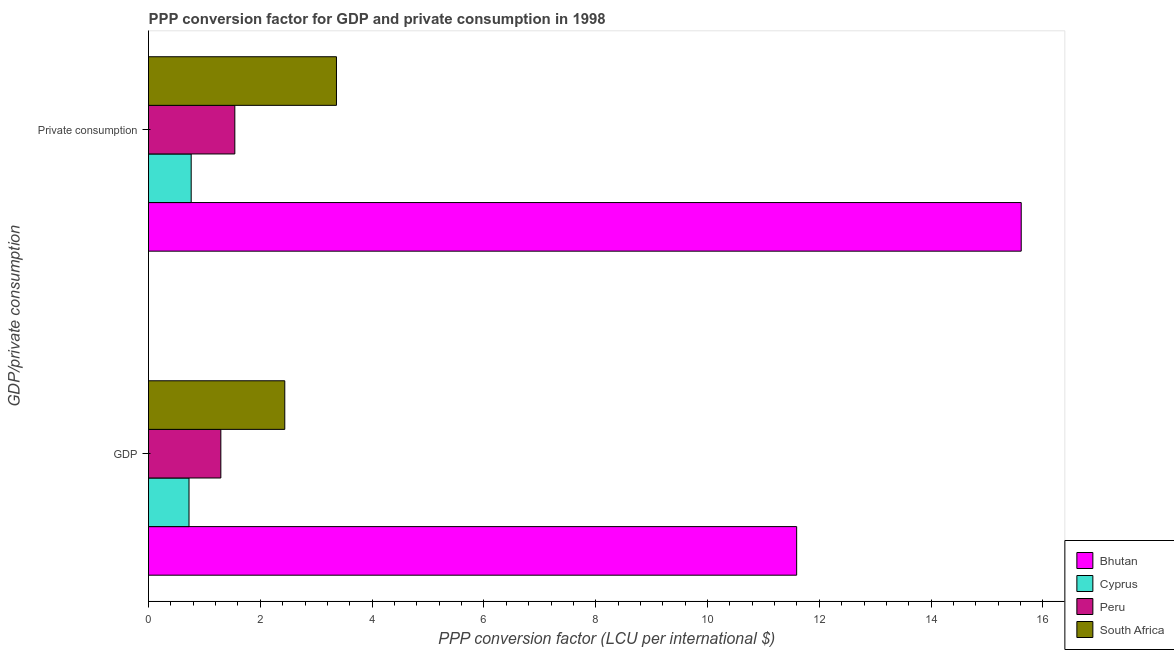How many different coloured bars are there?
Provide a succinct answer. 4. Are the number of bars per tick equal to the number of legend labels?
Your answer should be compact. Yes. What is the label of the 1st group of bars from the top?
Your response must be concise.  Private consumption. What is the ppp conversion factor for private consumption in Cyprus?
Provide a succinct answer. 0.76. Across all countries, what is the maximum ppp conversion factor for gdp?
Give a very brief answer. 11.59. Across all countries, what is the minimum ppp conversion factor for private consumption?
Ensure brevity in your answer.  0.76. In which country was the ppp conversion factor for private consumption maximum?
Provide a short and direct response. Bhutan. In which country was the ppp conversion factor for gdp minimum?
Provide a succinct answer. Cyprus. What is the total ppp conversion factor for private consumption in the graph?
Provide a short and direct response. 21.28. What is the difference between the ppp conversion factor for private consumption in South Africa and that in Bhutan?
Give a very brief answer. -12.25. What is the difference between the ppp conversion factor for private consumption in South Africa and the ppp conversion factor for gdp in Cyprus?
Your response must be concise. 2.64. What is the average ppp conversion factor for gdp per country?
Provide a short and direct response. 4.01. What is the difference between the ppp conversion factor for gdp and ppp conversion factor for private consumption in Peru?
Keep it short and to the point. -0.25. What is the ratio of the ppp conversion factor for gdp in South Africa to that in Cyprus?
Your response must be concise. 3.37. What does the 4th bar from the top in GDP represents?
Provide a succinct answer. Bhutan. What does the 2nd bar from the bottom in GDP represents?
Keep it short and to the point. Cyprus. Are all the bars in the graph horizontal?
Offer a very short reply. Yes. Does the graph contain any zero values?
Ensure brevity in your answer.  No. Does the graph contain grids?
Offer a terse response. No. Where does the legend appear in the graph?
Your answer should be very brief. Bottom right. What is the title of the graph?
Ensure brevity in your answer.  PPP conversion factor for GDP and private consumption in 1998. What is the label or title of the X-axis?
Ensure brevity in your answer.  PPP conversion factor (LCU per international $). What is the label or title of the Y-axis?
Ensure brevity in your answer.  GDP/private consumption. What is the PPP conversion factor (LCU per international $) in Bhutan in GDP?
Keep it short and to the point. 11.59. What is the PPP conversion factor (LCU per international $) in Cyprus in GDP?
Keep it short and to the point. 0.72. What is the PPP conversion factor (LCU per international $) of Peru in GDP?
Provide a succinct answer. 1.29. What is the PPP conversion factor (LCU per international $) of South Africa in GDP?
Provide a succinct answer. 2.44. What is the PPP conversion factor (LCU per international $) of Bhutan in  Private consumption?
Your answer should be compact. 15.61. What is the PPP conversion factor (LCU per international $) in Cyprus in  Private consumption?
Offer a terse response. 0.76. What is the PPP conversion factor (LCU per international $) in Peru in  Private consumption?
Provide a short and direct response. 1.54. What is the PPP conversion factor (LCU per international $) of South Africa in  Private consumption?
Your response must be concise. 3.36. Across all GDP/private consumption, what is the maximum PPP conversion factor (LCU per international $) in Bhutan?
Give a very brief answer. 15.61. Across all GDP/private consumption, what is the maximum PPP conversion factor (LCU per international $) in Cyprus?
Your answer should be very brief. 0.76. Across all GDP/private consumption, what is the maximum PPP conversion factor (LCU per international $) in Peru?
Ensure brevity in your answer.  1.54. Across all GDP/private consumption, what is the maximum PPP conversion factor (LCU per international $) in South Africa?
Make the answer very short. 3.36. Across all GDP/private consumption, what is the minimum PPP conversion factor (LCU per international $) in Bhutan?
Provide a succinct answer. 11.59. Across all GDP/private consumption, what is the minimum PPP conversion factor (LCU per international $) of Cyprus?
Make the answer very short. 0.72. Across all GDP/private consumption, what is the minimum PPP conversion factor (LCU per international $) of Peru?
Your answer should be compact. 1.29. Across all GDP/private consumption, what is the minimum PPP conversion factor (LCU per international $) in South Africa?
Ensure brevity in your answer.  2.44. What is the total PPP conversion factor (LCU per international $) of Bhutan in the graph?
Offer a terse response. 27.21. What is the total PPP conversion factor (LCU per international $) in Cyprus in the graph?
Your answer should be very brief. 1.49. What is the total PPP conversion factor (LCU per international $) in Peru in the graph?
Ensure brevity in your answer.  2.84. What is the total PPP conversion factor (LCU per international $) of South Africa in the graph?
Ensure brevity in your answer.  5.8. What is the difference between the PPP conversion factor (LCU per international $) in Bhutan in GDP and that in  Private consumption?
Your answer should be very brief. -4.02. What is the difference between the PPP conversion factor (LCU per international $) in Cyprus in GDP and that in  Private consumption?
Keep it short and to the point. -0.04. What is the difference between the PPP conversion factor (LCU per international $) in Peru in GDP and that in  Private consumption?
Provide a short and direct response. -0.25. What is the difference between the PPP conversion factor (LCU per international $) of South Africa in GDP and that in  Private consumption?
Make the answer very short. -0.92. What is the difference between the PPP conversion factor (LCU per international $) in Bhutan in GDP and the PPP conversion factor (LCU per international $) in Cyprus in  Private consumption?
Offer a terse response. 10.83. What is the difference between the PPP conversion factor (LCU per international $) of Bhutan in GDP and the PPP conversion factor (LCU per international $) of Peru in  Private consumption?
Give a very brief answer. 10.05. What is the difference between the PPP conversion factor (LCU per international $) of Bhutan in GDP and the PPP conversion factor (LCU per international $) of South Africa in  Private consumption?
Provide a short and direct response. 8.23. What is the difference between the PPP conversion factor (LCU per international $) in Cyprus in GDP and the PPP conversion factor (LCU per international $) in Peru in  Private consumption?
Offer a very short reply. -0.82. What is the difference between the PPP conversion factor (LCU per international $) in Cyprus in GDP and the PPP conversion factor (LCU per international $) in South Africa in  Private consumption?
Make the answer very short. -2.64. What is the difference between the PPP conversion factor (LCU per international $) of Peru in GDP and the PPP conversion factor (LCU per international $) of South Africa in  Private consumption?
Ensure brevity in your answer.  -2.07. What is the average PPP conversion factor (LCU per international $) of Bhutan per GDP/private consumption?
Ensure brevity in your answer.  13.6. What is the average PPP conversion factor (LCU per international $) in Cyprus per GDP/private consumption?
Make the answer very short. 0.74. What is the average PPP conversion factor (LCU per international $) of Peru per GDP/private consumption?
Provide a succinct answer. 1.42. What is the average PPP conversion factor (LCU per international $) of South Africa per GDP/private consumption?
Provide a succinct answer. 2.9. What is the difference between the PPP conversion factor (LCU per international $) of Bhutan and PPP conversion factor (LCU per international $) of Cyprus in GDP?
Make the answer very short. 10.87. What is the difference between the PPP conversion factor (LCU per international $) in Bhutan and PPP conversion factor (LCU per international $) in Peru in GDP?
Offer a terse response. 10.3. What is the difference between the PPP conversion factor (LCU per international $) of Bhutan and PPP conversion factor (LCU per international $) of South Africa in GDP?
Your answer should be very brief. 9.16. What is the difference between the PPP conversion factor (LCU per international $) in Cyprus and PPP conversion factor (LCU per international $) in Peru in GDP?
Ensure brevity in your answer.  -0.57. What is the difference between the PPP conversion factor (LCU per international $) of Cyprus and PPP conversion factor (LCU per international $) of South Africa in GDP?
Provide a succinct answer. -1.71. What is the difference between the PPP conversion factor (LCU per international $) of Peru and PPP conversion factor (LCU per international $) of South Africa in GDP?
Your answer should be compact. -1.14. What is the difference between the PPP conversion factor (LCU per international $) in Bhutan and PPP conversion factor (LCU per international $) in Cyprus in  Private consumption?
Give a very brief answer. 14.85. What is the difference between the PPP conversion factor (LCU per international $) in Bhutan and PPP conversion factor (LCU per international $) in Peru in  Private consumption?
Your response must be concise. 14.07. What is the difference between the PPP conversion factor (LCU per international $) in Bhutan and PPP conversion factor (LCU per international $) in South Africa in  Private consumption?
Your answer should be compact. 12.25. What is the difference between the PPP conversion factor (LCU per international $) in Cyprus and PPP conversion factor (LCU per international $) in Peru in  Private consumption?
Make the answer very short. -0.78. What is the difference between the PPP conversion factor (LCU per international $) of Cyprus and PPP conversion factor (LCU per international $) of South Africa in  Private consumption?
Your answer should be compact. -2.6. What is the difference between the PPP conversion factor (LCU per international $) in Peru and PPP conversion factor (LCU per international $) in South Africa in  Private consumption?
Make the answer very short. -1.82. What is the ratio of the PPP conversion factor (LCU per international $) of Bhutan in GDP to that in  Private consumption?
Keep it short and to the point. 0.74. What is the ratio of the PPP conversion factor (LCU per international $) of Cyprus in GDP to that in  Private consumption?
Provide a short and direct response. 0.95. What is the ratio of the PPP conversion factor (LCU per international $) of Peru in GDP to that in  Private consumption?
Provide a succinct answer. 0.84. What is the ratio of the PPP conversion factor (LCU per international $) of South Africa in GDP to that in  Private consumption?
Offer a very short reply. 0.72. What is the difference between the highest and the second highest PPP conversion factor (LCU per international $) of Bhutan?
Make the answer very short. 4.02. What is the difference between the highest and the second highest PPP conversion factor (LCU per international $) of Cyprus?
Offer a very short reply. 0.04. What is the difference between the highest and the second highest PPP conversion factor (LCU per international $) in Peru?
Keep it short and to the point. 0.25. What is the difference between the highest and the second highest PPP conversion factor (LCU per international $) of South Africa?
Provide a short and direct response. 0.92. What is the difference between the highest and the lowest PPP conversion factor (LCU per international $) of Bhutan?
Keep it short and to the point. 4.02. What is the difference between the highest and the lowest PPP conversion factor (LCU per international $) of Cyprus?
Keep it short and to the point. 0.04. What is the difference between the highest and the lowest PPP conversion factor (LCU per international $) in Peru?
Make the answer very short. 0.25. What is the difference between the highest and the lowest PPP conversion factor (LCU per international $) of South Africa?
Provide a short and direct response. 0.92. 